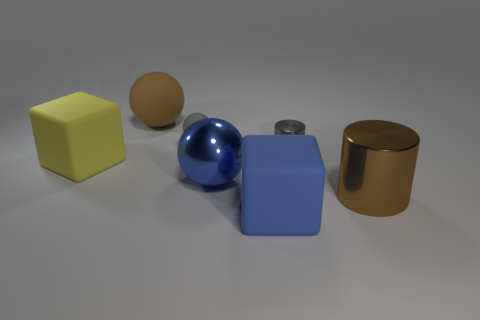Can you describe the colors of the objects in the image? Certainly! There is a yellow cube, a brown cylinder, a blue sphere, a greyish metallic cylinder, and a blue cube. Are these objects arranged in any specific pattern? The objects are somewhat scattered, with no clear pattern. They are placed on a flat surface with considerable space between them. 